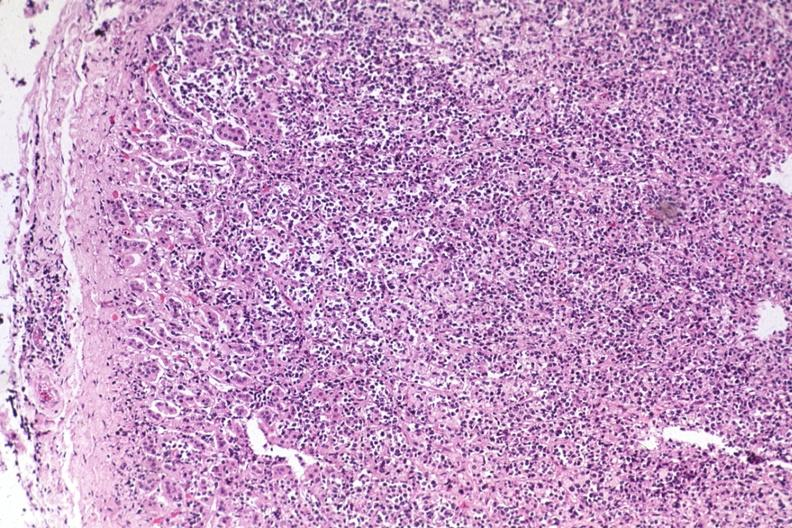s angiogram present?
Answer the question using a single word or phrase. No 